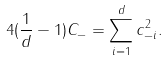Convert formula to latex. <formula><loc_0><loc_0><loc_500><loc_500>4 ( \frac { 1 } { d } - 1 ) C _ { - } = \sum _ { i = 1 } ^ { d } c _ { - i } ^ { 2 } .</formula> 